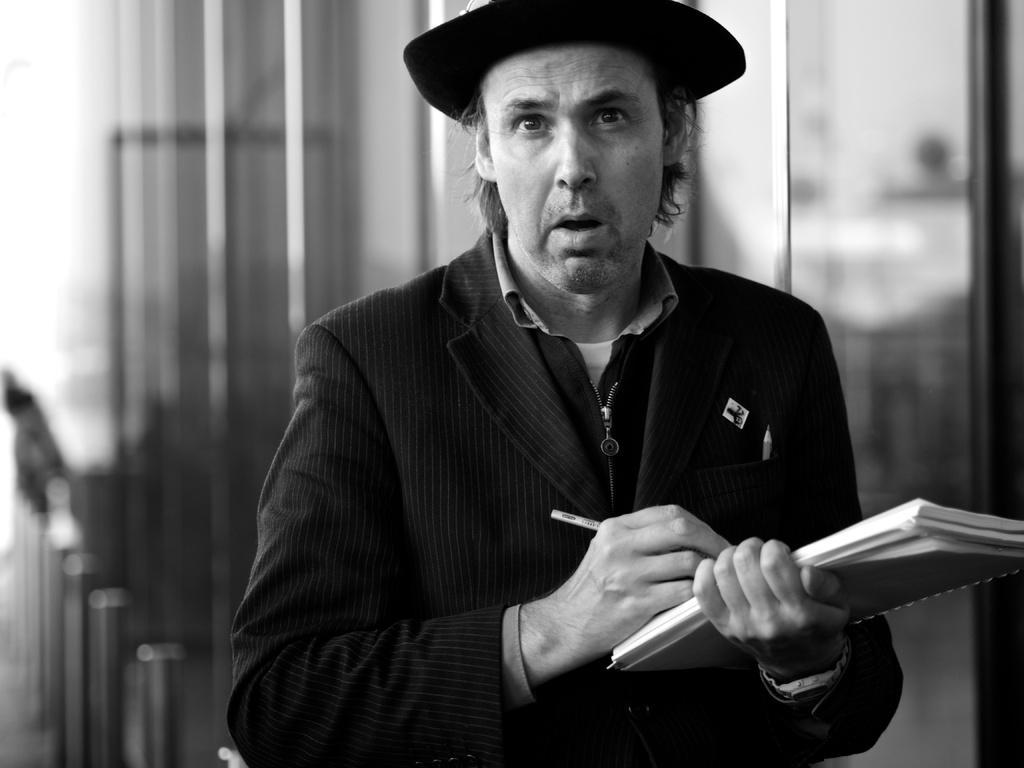In one or two sentences, can you explain what this image depicts? This is a black and white image. In this image we can see a person wearing a hat holding a book and a pen. On the backside we can see some glasses. 